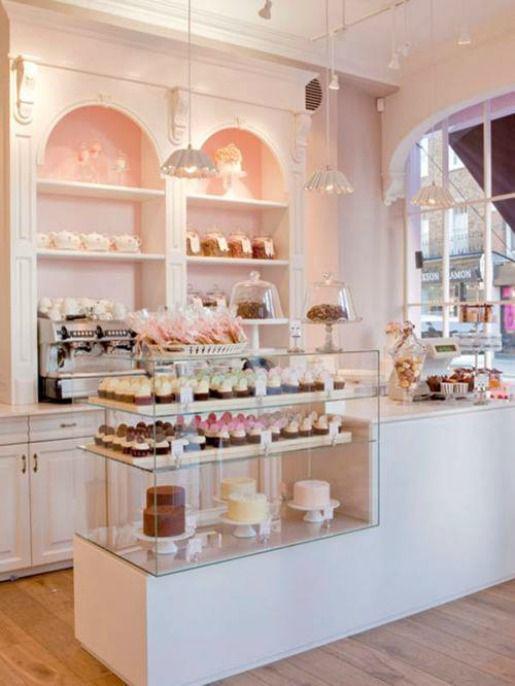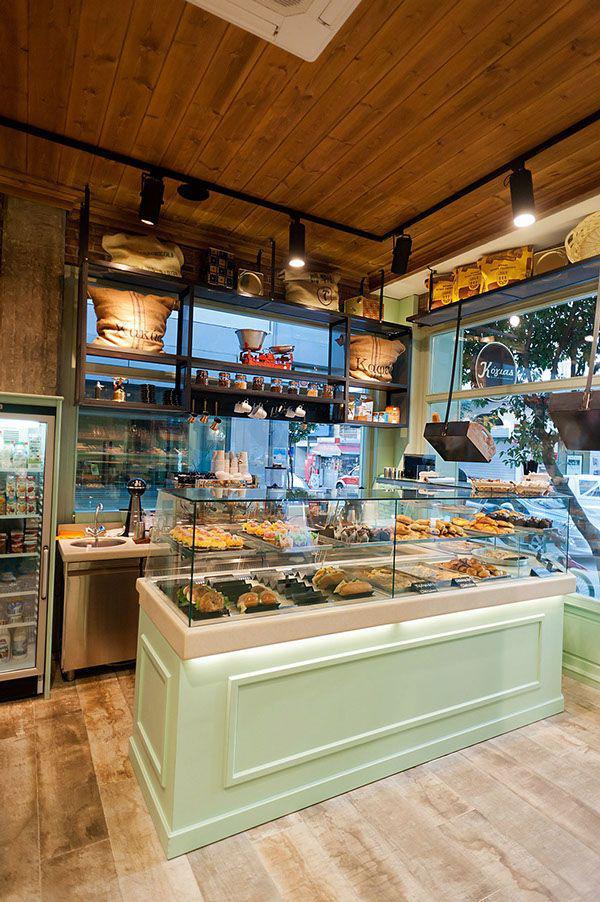The first image is the image on the left, the second image is the image on the right. For the images displayed, is the sentence "An image contains a view of a storefront from an outside perspective." factually correct? Answer yes or no. No. The first image is the image on the left, the second image is the image on the right. Assess this claim about the two images: "There are tables and chairs for the customers.". Correct or not? Answer yes or no. No. 